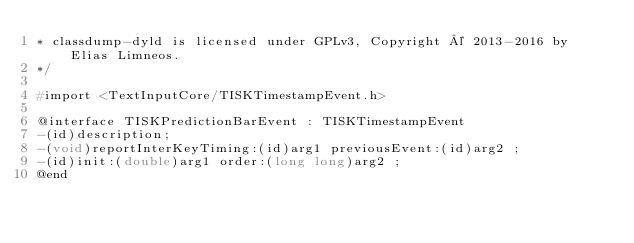Convert code to text. <code><loc_0><loc_0><loc_500><loc_500><_C_>* classdump-dyld is licensed under GPLv3, Copyright © 2013-2016 by Elias Limneos.
*/

#import <TextInputCore/TISKTimestampEvent.h>

@interface TISKPredictionBarEvent : TISKTimestampEvent
-(id)description;
-(void)reportInterKeyTiming:(id)arg1 previousEvent:(id)arg2 ;
-(id)init:(double)arg1 order:(long long)arg2 ;
@end

</code> 